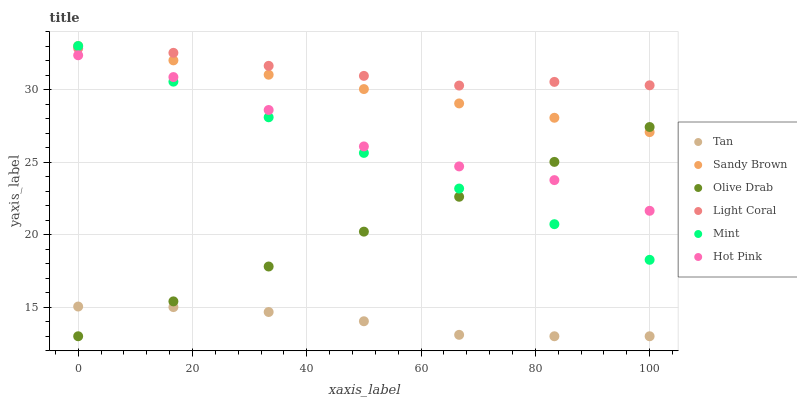Does Tan have the minimum area under the curve?
Answer yes or no. Yes. Does Light Coral have the maximum area under the curve?
Answer yes or no. Yes. Does Hot Pink have the minimum area under the curve?
Answer yes or no. No. Does Hot Pink have the maximum area under the curve?
Answer yes or no. No. Is Sandy Brown the smoothest?
Answer yes or no. Yes. Is Hot Pink the roughest?
Answer yes or no. Yes. Is Light Coral the smoothest?
Answer yes or no. No. Is Light Coral the roughest?
Answer yes or no. No. Does Tan have the lowest value?
Answer yes or no. Yes. Does Hot Pink have the lowest value?
Answer yes or no. No. Does Mint have the highest value?
Answer yes or no. Yes. Does Hot Pink have the highest value?
Answer yes or no. No. Is Tan less than Sandy Brown?
Answer yes or no. Yes. Is Sandy Brown greater than Tan?
Answer yes or no. Yes. Does Mint intersect Hot Pink?
Answer yes or no. Yes. Is Mint less than Hot Pink?
Answer yes or no. No. Is Mint greater than Hot Pink?
Answer yes or no. No. Does Tan intersect Sandy Brown?
Answer yes or no. No. 